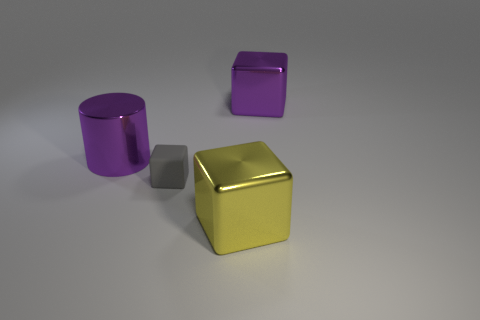Add 3 small gray objects. How many objects exist? 7 Subtract all cylinders. How many objects are left? 3 Add 1 big metallic objects. How many big metallic objects exist? 4 Subtract 0 brown cubes. How many objects are left? 4 Subtract all big purple things. Subtract all blue rubber blocks. How many objects are left? 2 Add 4 large yellow things. How many large yellow things are left? 5 